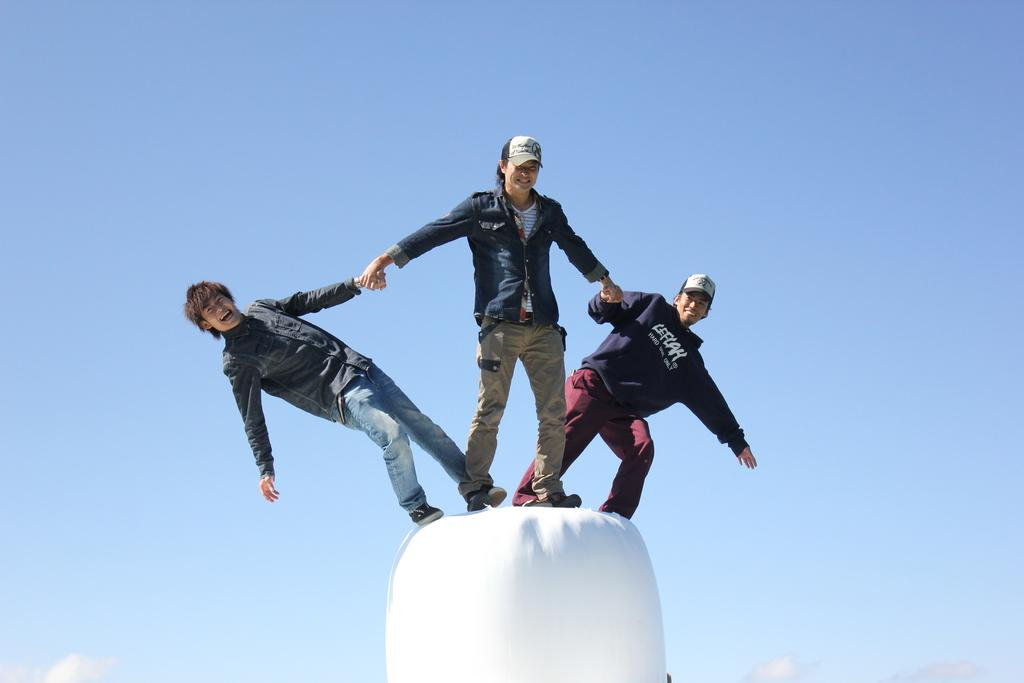How many people are present in the image? There are three people in the image. What are the people wearing on their heads? Some of the people are wearing caps. What is the facial expression of the people in the image? The people are smiling. What type of boat can be seen in the background of the image? There is no boat present in the image; it only features three people. 